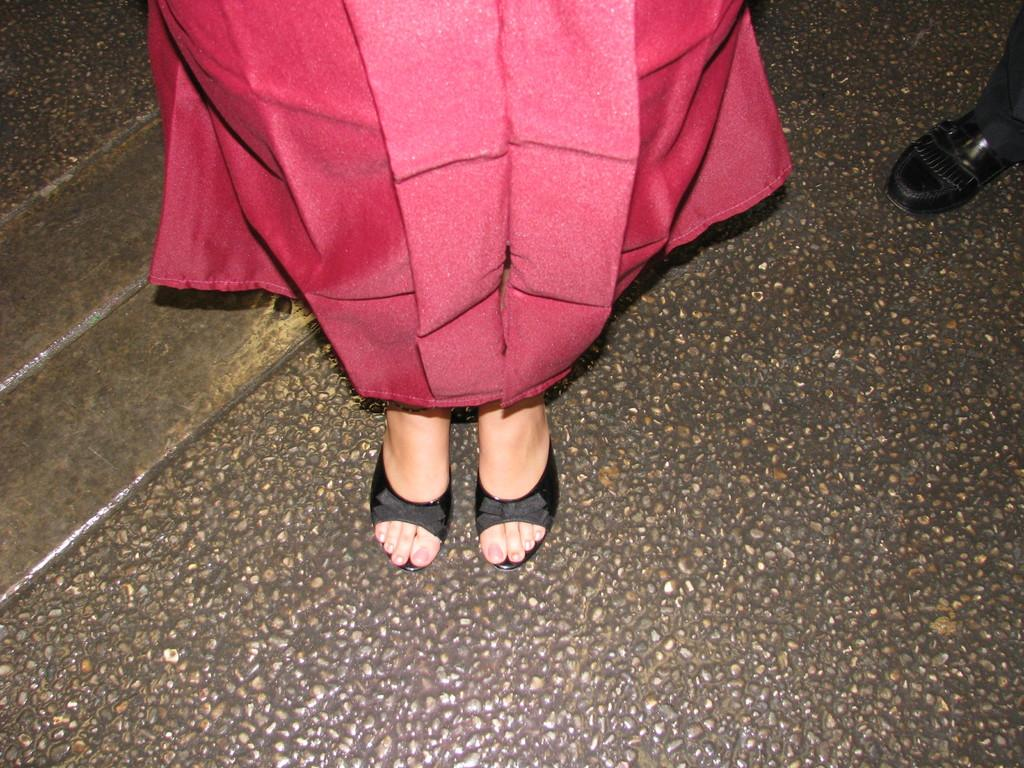What is the main subject in the center of the image? There are legs of a person wearing a red color dress in the center of the image. What else can be seen on the right side of the image? There is a shoe of a person on the right side of the image. What type of surface is visible at the bottom of the image? There is a road visible at the bottom of the image. Can you tell me what statement the sea is making in the image? There is no sea present in the image, so it cannot make any statements. 